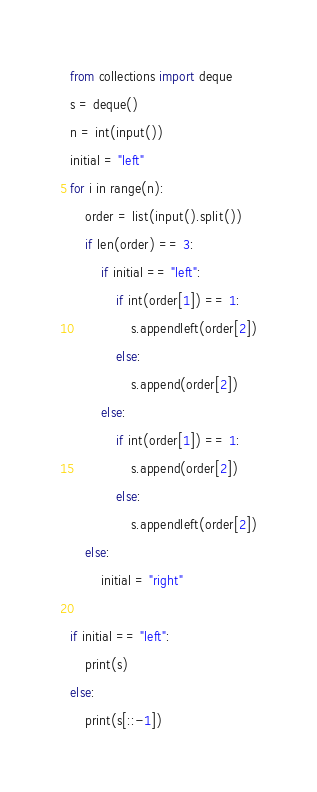Convert code to text. <code><loc_0><loc_0><loc_500><loc_500><_Python_>from collections import deque
s = deque()
n = int(input())
initial = "left"
for i in range(n):
    order = list(input().split())
    if len(order) == 3:
        if initial == "left":
            if int(order[1]) == 1:
                s.appendleft(order[2])
            else:
                s.append(order[2])
        else:
            if int(order[1]) == 1:
                s.append(order[2])
            else:
                s.appendleft(order[2])
    else:
        initial = "right"
    
if initial == "left":
    print(s)
else:
    print(s[::-1])</code> 